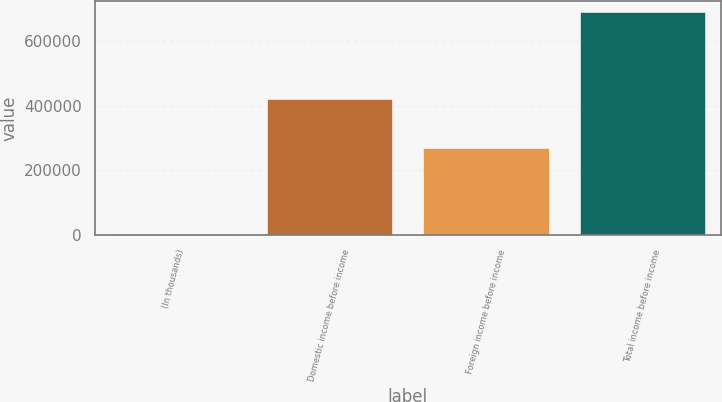<chart> <loc_0><loc_0><loc_500><loc_500><bar_chart><fcel>(In thousands)<fcel>Domestic income before income<fcel>Foreign income before income<fcel>Total income before income<nl><fcel>2013<fcel>420862<fcel>269759<fcel>690621<nl></chart> 